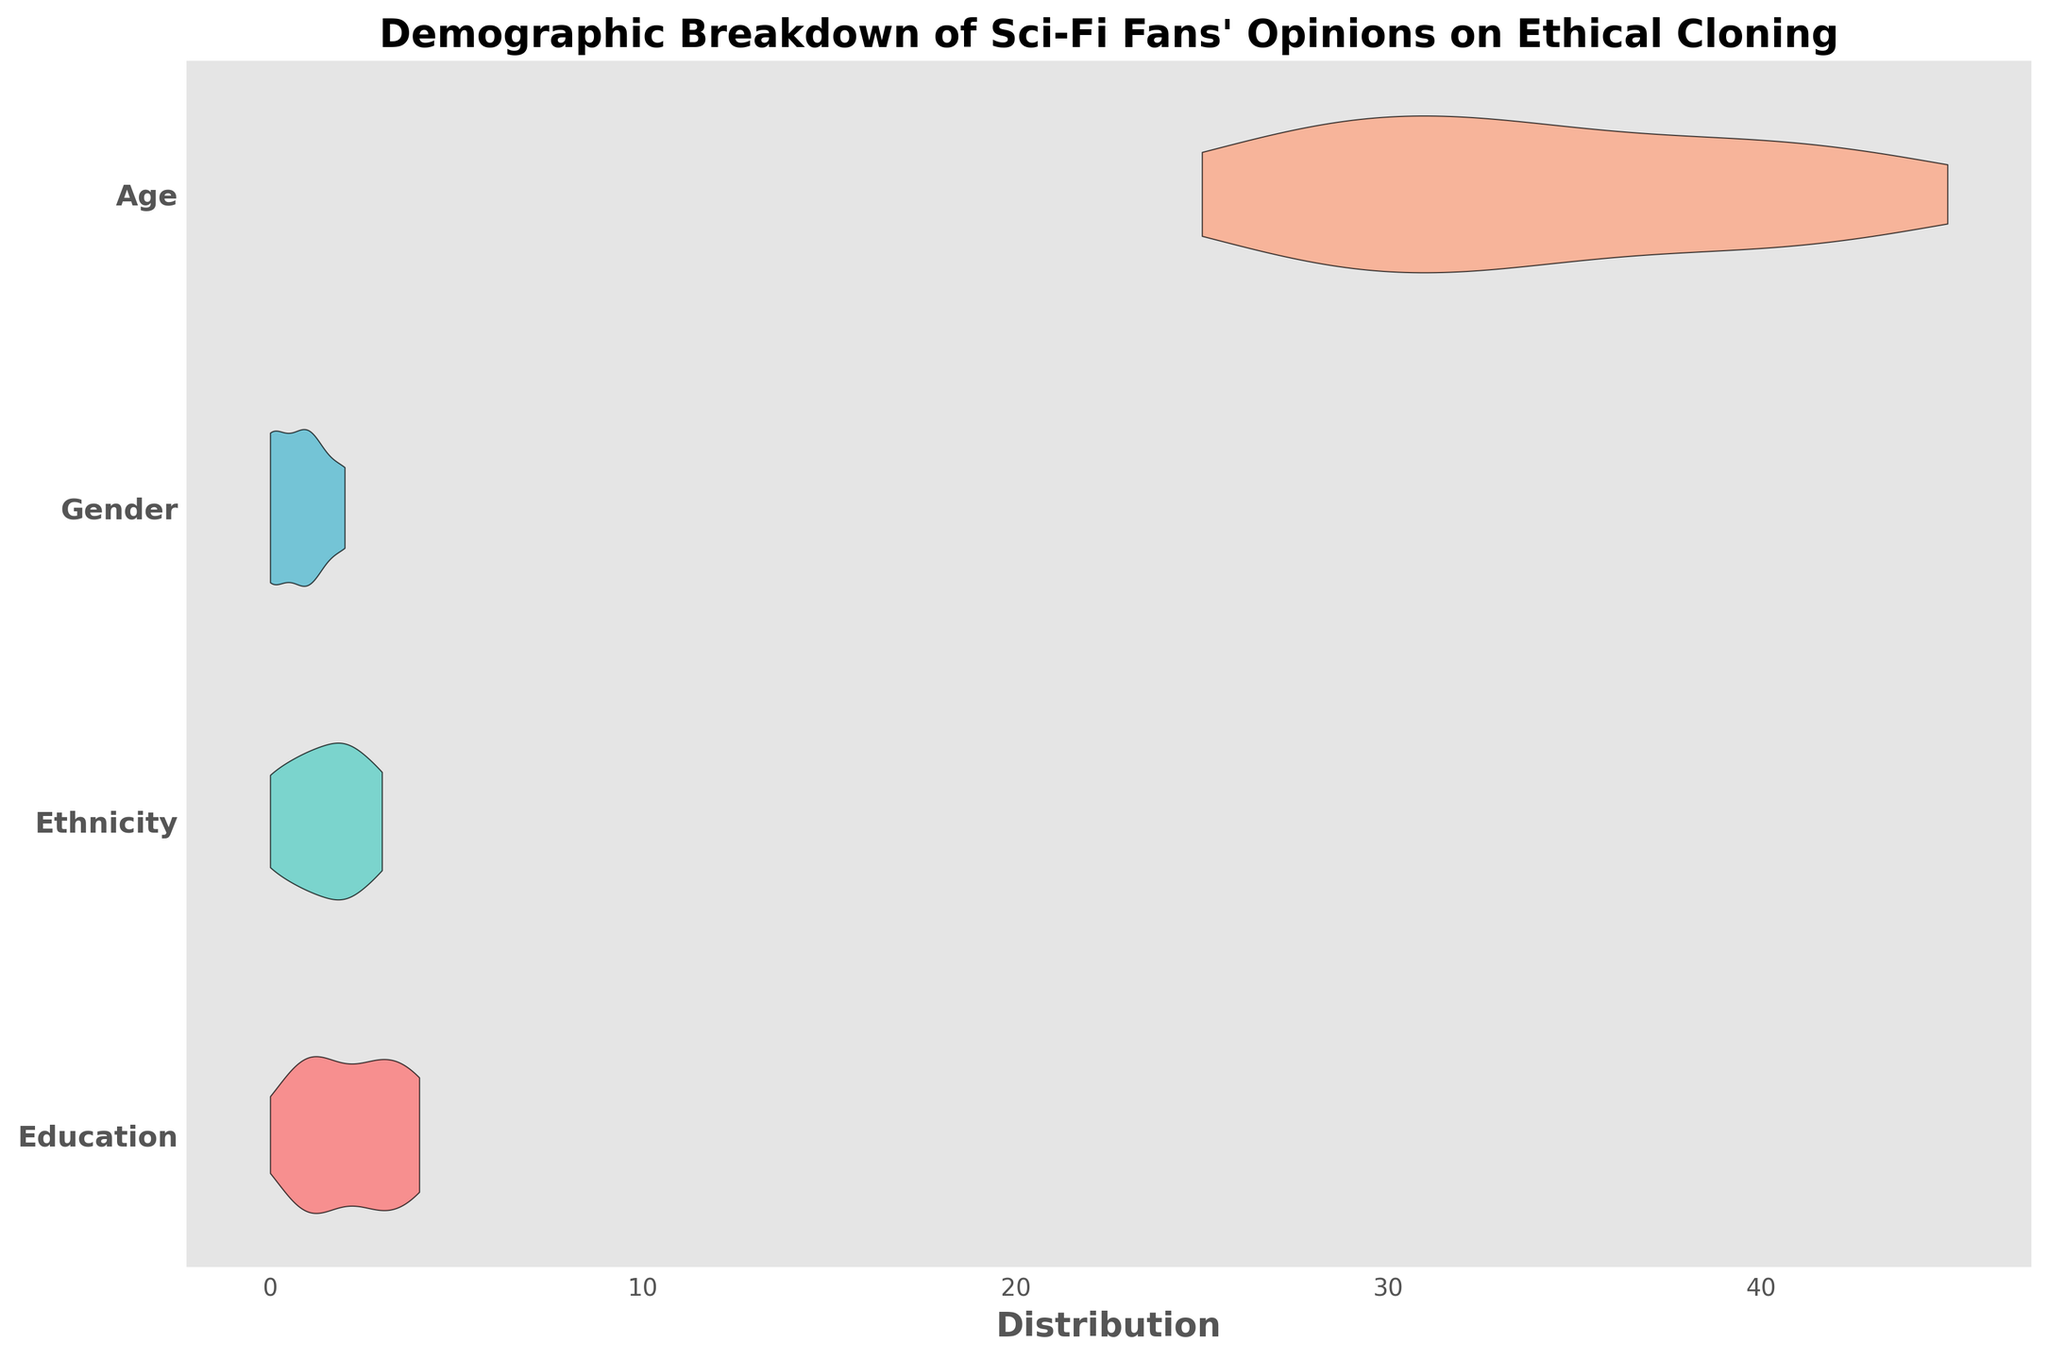How many demographic categories are represented in the chart? The title implies that the chart breaks down opinions by several demographic factors. By looking at the y-axis labels, we can count the number of categories mentioned: Education, Ethnicity, Gender, and Age.
Answer: Four Which category's distribution appears to have the widest spread? A wider violin shape indicates a broader spread of data points. By observing the chart, the shape with the widest spread can be identified.
Answer: Age Which demographic group has the smallest distribution spread in their opinion scores? In a violin plot, the smallest distribution spread is indicated by the thinnest section. By analyzing the width of the violins for each category, the one with the thinnest section represents the smallest spread.
Answer: Gender Is the median opinion score visually represented in the chart? To check if the median is visually represented, we need to look for any markers in the violin plot such as lines or special symbols that might indicate it. If no such indicators are visible, the answer is no.
Answer: No What color represents the Ethnicity category in the chart? By identifying the color segments corresponding to the Ethnicity label on the y-axis, we can determine the color associated with it.
Answer: Green Does any demographic category show a clear bimodal distribution? A bimodal distribution has two peaks. By checking each violin plot for the presence of two distinct peaks, we can determine if any category shows bimodality.
Answer: No Which category tends to have the highest scores overall? The highest scores are indicated by the rightmost stretches of the violin plots. By observing which category's violin extends furthest to the right, we can determine the overall trend.
Answer: Education What is the title of the figure? The title is often found at the top of the chart and provides a summary of what the figure is about. In this case, we look at the top of the chart for the title.
Answer: Demographic Breakdown of Sci-Fi Fans' Opinions on Ethical Cloning 